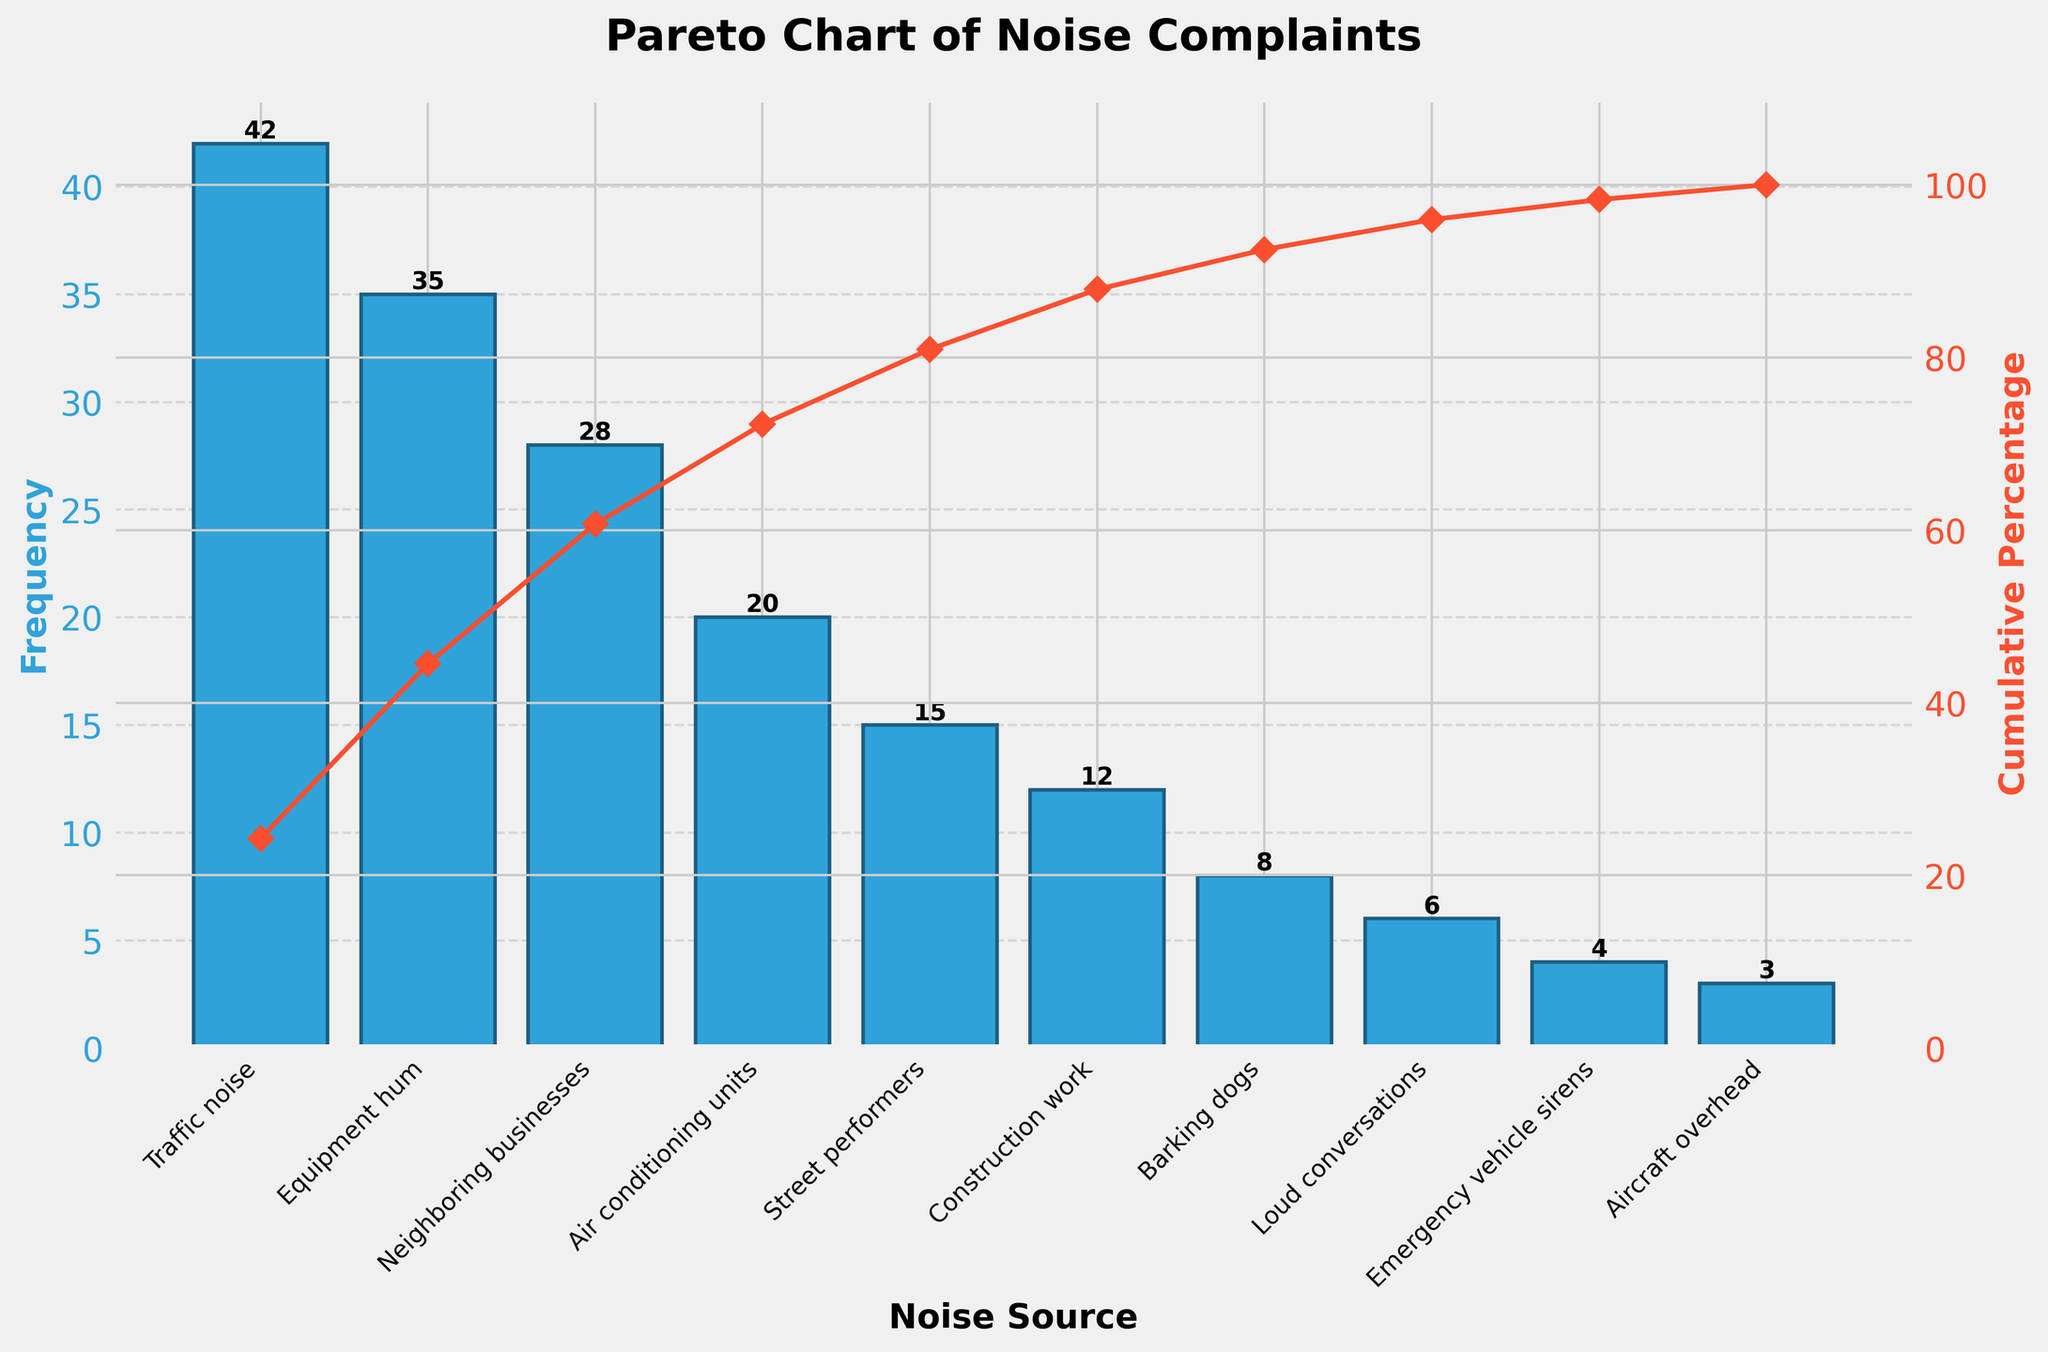How many different noise sources are displayed in the chart? Count the number of unique noise sources listed on the x-axis.
Answer: 10 Which noise source has the highest frequency? Identify the tallest bar in the bar chart and check its corresponding label on the x-axis.
Answer: Traffic noise What is the cumulative percentage after the first two noise sources? Sum the cumulative percentages of the first two bars. The cumulative percentage for Traffic noise is 33.6%, and for Equipment hum, it is 60.4%.
Answer: 60.4% How many noise sources have a frequency less than 10? Count the bars that have a height lower than 10 based on the y-axis. These are Barking dogs, Loud conversations, Emergency vehicle sirens, and Aircraft overhead.
Answer: 4 What is the total frequency of noise complaints from Traffic noise and Equipment hum? Add the frequencies for these two noise sources: 42 (Traffic noise) + 35 (Equipment hum), which equals 77.
Answer: 77 By what percentage does the cumulative percentage increase from Equipment hum to Neighboring businesses? Subtract the cumulative percentage of Equipment hum (60.4%) from Neighboring businesses (80.8%).
Answer: 20.4% Which noise source falls exactly at the cumulative percentage of 80.8%? Identify the noise source corresponding to the cumulative percentage of 80.8% on the line graph.
Answer: Neighboring businesses Compare the frequencies of Air conditioning units and Street performers. Which one has a higher frequency and by how much? Air conditioning units have 20 and Street performers have 15. Subtract the latter from the former: 20 - 15 = 5.
Answer: Air conditioning units by 5 What is the average frequency of the noise sources? Sum all frequencies and divide by the number of noise sources: (42 + 35 + 28 + 20 + 15 + 12 + 8 + 6 + 4 + 3) / 10 = 173 / 10 = 17.3
Answer: 17.3 What is the combined cumulative percentage of the top three noise sources? Sum the cumulative percentages of these sources (Traffic noise, Equipment hum, Neighboring businesses): 33.6% + 60.4% + 80.8%
Answer: 80.8% 